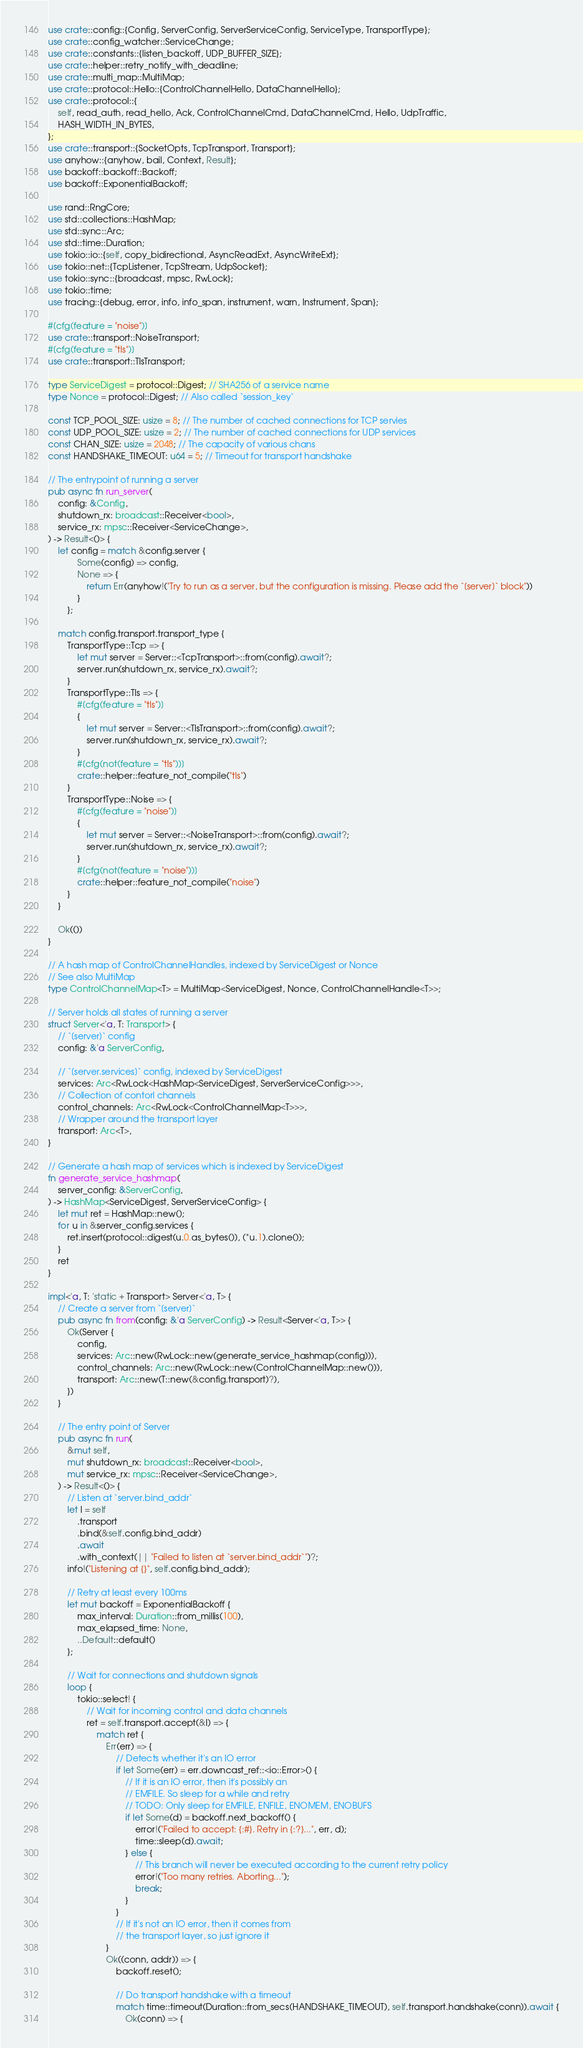<code> <loc_0><loc_0><loc_500><loc_500><_Rust_>use crate::config::{Config, ServerConfig, ServerServiceConfig, ServiceType, TransportType};
use crate::config_watcher::ServiceChange;
use crate::constants::{listen_backoff, UDP_BUFFER_SIZE};
use crate::helper::retry_notify_with_deadline;
use crate::multi_map::MultiMap;
use crate::protocol::Hello::{ControlChannelHello, DataChannelHello};
use crate::protocol::{
    self, read_auth, read_hello, Ack, ControlChannelCmd, DataChannelCmd, Hello, UdpTraffic,
    HASH_WIDTH_IN_BYTES,
};
use crate::transport::{SocketOpts, TcpTransport, Transport};
use anyhow::{anyhow, bail, Context, Result};
use backoff::backoff::Backoff;
use backoff::ExponentialBackoff;

use rand::RngCore;
use std::collections::HashMap;
use std::sync::Arc;
use std::time::Duration;
use tokio::io::{self, copy_bidirectional, AsyncReadExt, AsyncWriteExt};
use tokio::net::{TcpListener, TcpStream, UdpSocket};
use tokio::sync::{broadcast, mpsc, RwLock};
use tokio::time;
use tracing::{debug, error, info, info_span, instrument, warn, Instrument, Span};

#[cfg(feature = "noise")]
use crate::transport::NoiseTransport;
#[cfg(feature = "tls")]
use crate::transport::TlsTransport;

type ServiceDigest = protocol::Digest; // SHA256 of a service name
type Nonce = protocol::Digest; // Also called `session_key`

const TCP_POOL_SIZE: usize = 8; // The number of cached connections for TCP servies
const UDP_POOL_SIZE: usize = 2; // The number of cached connections for UDP services
const CHAN_SIZE: usize = 2048; // The capacity of various chans
const HANDSHAKE_TIMEOUT: u64 = 5; // Timeout for transport handshake

// The entrypoint of running a server
pub async fn run_server(
    config: &Config,
    shutdown_rx: broadcast::Receiver<bool>,
    service_rx: mpsc::Receiver<ServiceChange>,
) -> Result<()> {
    let config = match &config.server {
            Some(config) => config,
            None => {
                return Err(anyhow!("Try to run as a server, but the configuration is missing. Please add the `[server]` block"))
            }
        };

    match config.transport.transport_type {
        TransportType::Tcp => {
            let mut server = Server::<TcpTransport>::from(config).await?;
            server.run(shutdown_rx, service_rx).await?;
        }
        TransportType::Tls => {
            #[cfg(feature = "tls")]
            {
                let mut server = Server::<TlsTransport>::from(config).await?;
                server.run(shutdown_rx, service_rx).await?;
            }
            #[cfg(not(feature = "tls"))]
            crate::helper::feature_not_compile("tls")
        }
        TransportType::Noise => {
            #[cfg(feature = "noise")]
            {
                let mut server = Server::<NoiseTransport>::from(config).await?;
                server.run(shutdown_rx, service_rx).await?;
            }
            #[cfg(not(feature = "noise"))]
            crate::helper::feature_not_compile("noise")
        }
    }

    Ok(())
}

// A hash map of ControlChannelHandles, indexed by ServiceDigest or Nonce
// See also MultiMap
type ControlChannelMap<T> = MultiMap<ServiceDigest, Nonce, ControlChannelHandle<T>>;

// Server holds all states of running a server
struct Server<'a, T: Transport> {
    // `[server]` config
    config: &'a ServerConfig,

    // `[server.services]` config, indexed by ServiceDigest
    services: Arc<RwLock<HashMap<ServiceDigest, ServerServiceConfig>>>,
    // Collection of contorl channels
    control_channels: Arc<RwLock<ControlChannelMap<T>>>,
    // Wrapper around the transport layer
    transport: Arc<T>,
}

// Generate a hash map of services which is indexed by ServiceDigest
fn generate_service_hashmap(
    server_config: &ServerConfig,
) -> HashMap<ServiceDigest, ServerServiceConfig> {
    let mut ret = HashMap::new();
    for u in &server_config.services {
        ret.insert(protocol::digest(u.0.as_bytes()), (*u.1).clone());
    }
    ret
}

impl<'a, T: 'static + Transport> Server<'a, T> {
    // Create a server from `[server]`
    pub async fn from(config: &'a ServerConfig) -> Result<Server<'a, T>> {
        Ok(Server {
            config,
            services: Arc::new(RwLock::new(generate_service_hashmap(config))),
            control_channels: Arc::new(RwLock::new(ControlChannelMap::new())),
            transport: Arc::new(T::new(&config.transport)?),
        })
    }

    // The entry point of Server
    pub async fn run(
        &mut self,
        mut shutdown_rx: broadcast::Receiver<bool>,
        mut service_rx: mpsc::Receiver<ServiceChange>,
    ) -> Result<()> {
        // Listen at `server.bind_addr`
        let l = self
            .transport
            .bind(&self.config.bind_addr)
            .await
            .with_context(|| "Failed to listen at `server.bind_addr`")?;
        info!("Listening at {}", self.config.bind_addr);

        // Retry at least every 100ms
        let mut backoff = ExponentialBackoff {
            max_interval: Duration::from_millis(100),
            max_elapsed_time: None,
            ..Default::default()
        };

        // Wait for connections and shutdown signals
        loop {
            tokio::select! {
                // Wait for incoming control and data channels
                ret = self.transport.accept(&l) => {
                    match ret {
                        Err(err) => {
                            // Detects whether it's an IO error
                            if let Some(err) = err.downcast_ref::<io::Error>() {
                                // If it is an IO error, then it's possibly an
                                // EMFILE. So sleep for a while and retry
                                // TODO: Only sleep for EMFILE, ENFILE, ENOMEM, ENOBUFS
                                if let Some(d) = backoff.next_backoff() {
                                    error!("Failed to accept: {:#}. Retry in {:?}...", err, d);
                                    time::sleep(d).await;
                                } else {
                                    // This branch will never be executed according to the current retry policy
                                    error!("Too many retries. Aborting...");
                                    break;
                                }
                            }
                            // If it's not an IO error, then it comes from
                            // the transport layer, so just ignore it
                        }
                        Ok((conn, addr)) => {
                            backoff.reset();

                            // Do transport handshake with a timeout
                            match time::timeout(Duration::from_secs(HANDSHAKE_TIMEOUT), self.transport.handshake(conn)).await {
                                Ok(conn) => {</code> 